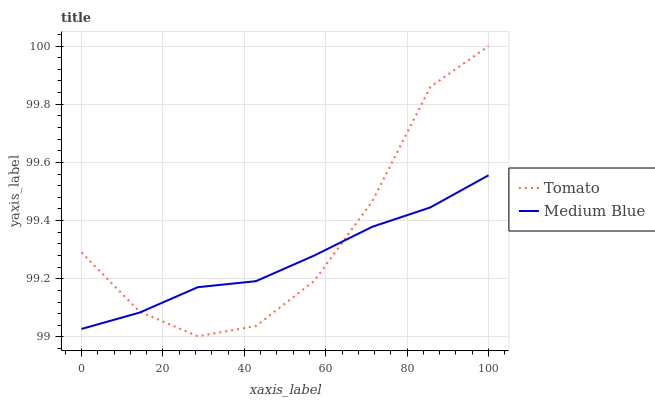Does Medium Blue have the minimum area under the curve?
Answer yes or no. Yes. Does Tomato have the maximum area under the curve?
Answer yes or no. Yes. Does Medium Blue have the maximum area under the curve?
Answer yes or no. No. Is Medium Blue the smoothest?
Answer yes or no. Yes. Is Tomato the roughest?
Answer yes or no. Yes. Is Medium Blue the roughest?
Answer yes or no. No. Does Tomato have the lowest value?
Answer yes or no. Yes. Does Medium Blue have the lowest value?
Answer yes or no. No. Does Tomato have the highest value?
Answer yes or no. Yes. Does Medium Blue have the highest value?
Answer yes or no. No. Does Tomato intersect Medium Blue?
Answer yes or no. Yes. Is Tomato less than Medium Blue?
Answer yes or no. No. Is Tomato greater than Medium Blue?
Answer yes or no. No. 